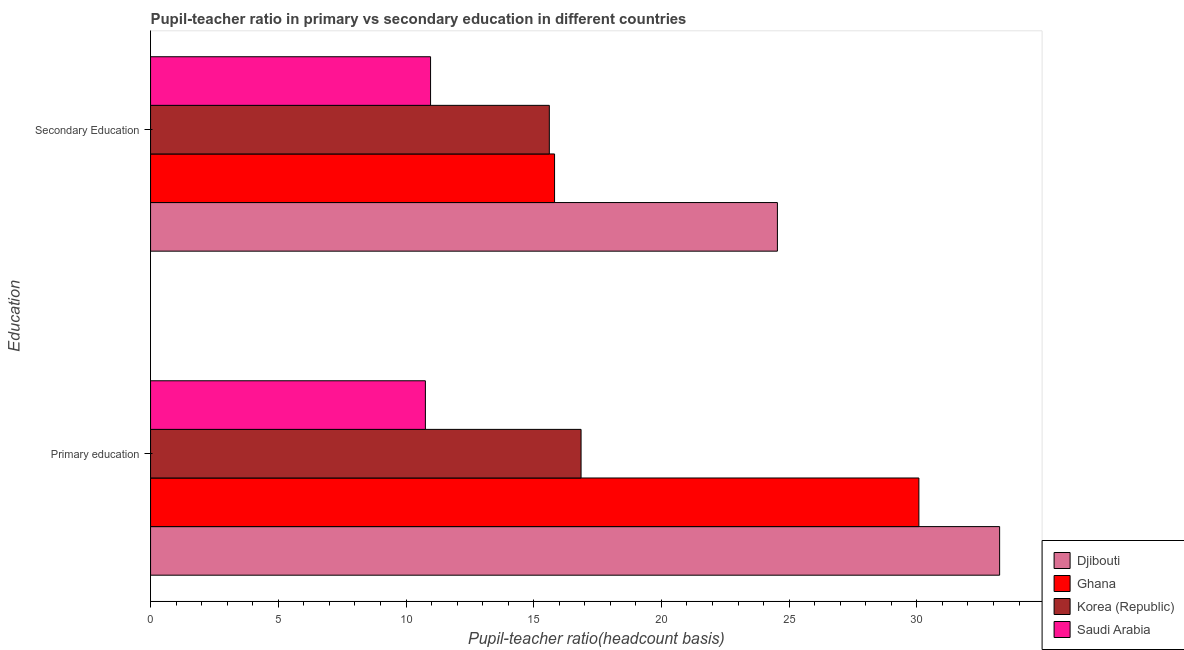Are the number of bars per tick equal to the number of legend labels?
Ensure brevity in your answer.  Yes. How many bars are there on the 1st tick from the top?
Provide a short and direct response. 4. What is the label of the 1st group of bars from the top?
Provide a short and direct response. Secondary Education. What is the pupil-teacher ratio in primary education in Saudi Arabia?
Provide a succinct answer. 10.76. Across all countries, what is the maximum pupil-teacher ratio in primary education?
Give a very brief answer. 33.24. Across all countries, what is the minimum pupil-teacher ratio in primary education?
Your answer should be very brief. 10.76. In which country was the pupil-teacher ratio in primary education maximum?
Make the answer very short. Djibouti. In which country was the pupil teacher ratio on secondary education minimum?
Offer a very short reply. Saudi Arabia. What is the total pupil teacher ratio on secondary education in the graph?
Keep it short and to the point. 66.93. What is the difference between the pupil teacher ratio on secondary education in Djibouti and that in Saudi Arabia?
Provide a short and direct response. 13.58. What is the difference between the pupil teacher ratio on secondary education in Saudi Arabia and the pupil-teacher ratio in primary education in Korea (Republic)?
Offer a very short reply. -5.89. What is the average pupil teacher ratio on secondary education per country?
Ensure brevity in your answer.  16.73. What is the difference between the pupil-teacher ratio in primary education and pupil teacher ratio on secondary education in Ghana?
Offer a very short reply. 14.26. What is the ratio of the pupil-teacher ratio in primary education in Djibouti to that in Saudi Arabia?
Offer a terse response. 3.09. In how many countries, is the pupil-teacher ratio in primary education greater than the average pupil-teacher ratio in primary education taken over all countries?
Offer a terse response. 2. What does the 3rd bar from the bottom in Secondary Education represents?
Provide a short and direct response. Korea (Republic). How many bars are there?
Make the answer very short. 8. Are all the bars in the graph horizontal?
Your response must be concise. Yes. Does the graph contain any zero values?
Offer a very short reply. No. Does the graph contain grids?
Make the answer very short. No. Where does the legend appear in the graph?
Your response must be concise. Bottom right. How many legend labels are there?
Provide a short and direct response. 4. How are the legend labels stacked?
Ensure brevity in your answer.  Vertical. What is the title of the graph?
Make the answer very short. Pupil-teacher ratio in primary vs secondary education in different countries. Does "Central African Republic" appear as one of the legend labels in the graph?
Your answer should be compact. No. What is the label or title of the X-axis?
Your answer should be compact. Pupil-teacher ratio(headcount basis). What is the label or title of the Y-axis?
Your answer should be compact. Education. What is the Pupil-teacher ratio(headcount basis) in Djibouti in Primary education?
Your answer should be very brief. 33.24. What is the Pupil-teacher ratio(headcount basis) of Ghana in Primary education?
Provide a short and direct response. 30.08. What is the Pupil-teacher ratio(headcount basis) of Korea (Republic) in Primary education?
Your response must be concise. 16.85. What is the Pupil-teacher ratio(headcount basis) of Saudi Arabia in Primary education?
Your answer should be compact. 10.76. What is the Pupil-teacher ratio(headcount basis) in Djibouti in Secondary Education?
Your answer should be very brief. 24.54. What is the Pupil-teacher ratio(headcount basis) of Ghana in Secondary Education?
Provide a short and direct response. 15.82. What is the Pupil-teacher ratio(headcount basis) in Korea (Republic) in Secondary Education?
Ensure brevity in your answer.  15.61. What is the Pupil-teacher ratio(headcount basis) of Saudi Arabia in Secondary Education?
Ensure brevity in your answer.  10.96. Across all Education, what is the maximum Pupil-teacher ratio(headcount basis) of Djibouti?
Keep it short and to the point. 33.24. Across all Education, what is the maximum Pupil-teacher ratio(headcount basis) of Ghana?
Your response must be concise. 30.08. Across all Education, what is the maximum Pupil-teacher ratio(headcount basis) in Korea (Republic)?
Your answer should be very brief. 16.85. Across all Education, what is the maximum Pupil-teacher ratio(headcount basis) in Saudi Arabia?
Your answer should be very brief. 10.96. Across all Education, what is the minimum Pupil-teacher ratio(headcount basis) in Djibouti?
Your answer should be very brief. 24.54. Across all Education, what is the minimum Pupil-teacher ratio(headcount basis) in Ghana?
Ensure brevity in your answer.  15.82. Across all Education, what is the minimum Pupil-teacher ratio(headcount basis) of Korea (Republic)?
Provide a short and direct response. 15.61. Across all Education, what is the minimum Pupil-teacher ratio(headcount basis) in Saudi Arabia?
Make the answer very short. 10.76. What is the total Pupil-teacher ratio(headcount basis) in Djibouti in the graph?
Provide a short and direct response. 57.78. What is the total Pupil-teacher ratio(headcount basis) of Ghana in the graph?
Offer a terse response. 45.89. What is the total Pupil-teacher ratio(headcount basis) of Korea (Republic) in the graph?
Ensure brevity in your answer.  32.46. What is the total Pupil-teacher ratio(headcount basis) in Saudi Arabia in the graph?
Make the answer very short. 21.72. What is the difference between the Pupil-teacher ratio(headcount basis) in Djibouti in Primary education and that in Secondary Education?
Your response must be concise. 8.7. What is the difference between the Pupil-teacher ratio(headcount basis) in Ghana in Primary education and that in Secondary Education?
Make the answer very short. 14.26. What is the difference between the Pupil-teacher ratio(headcount basis) in Korea (Republic) in Primary education and that in Secondary Education?
Keep it short and to the point. 1.24. What is the difference between the Pupil-teacher ratio(headcount basis) in Saudi Arabia in Primary education and that in Secondary Education?
Give a very brief answer. -0.2. What is the difference between the Pupil-teacher ratio(headcount basis) in Djibouti in Primary education and the Pupil-teacher ratio(headcount basis) in Ghana in Secondary Education?
Give a very brief answer. 17.42. What is the difference between the Pupil-teacher ratio(headcount basis) in Djibouti in Primary education and the Pupil-teacher ratio(headcount basis) in Korea (Republic) in Secondary Education?
Offer a terse response. 17.63. What is the difference between the Pupil-teacher ratio(headcount basis) in Djibouti in Primary education and the Pupil-teacher ratio(headcount basis) in Saudi Arabia in Secondary Education?
Keep it short and to the point. 22.28. What is the difference between the Pupil-teacher ratio(headcount basis) of Ghana in Primary education and the Pupil-teacher ratio(headcount basis) of Korea (Republic) in Secondary Education?
Your response must be concise. 14.47. What is the difference between the Pupil-teacher ratio(headcount basis) in Ghana in Primary education and the Pupil-teacher ratio(headcount basis) in Saudi Arabia in Secondary Education?
Offer a very short reply. 19.12. What is the difference between the Pupil-teacher ratio(headcount basis) in Korea (Republic) in Primary education and the Pupil-teacher ratio(headcount basis) in Saudi Arabia in Secondary Education?
Provide a short and direct response. 5.89. What is the average Pupil-teacher ratio(headcount basis) in Djibouti per Education?
Provide a succinct answer. 28.89. What is the average Pupil-teacher ratio(headcount basis) in Ghana per Education?
Provide a short and direct response. 22.95. What is the average Pupil-teacher ratio(headcount basis) in Korea (Republic) per Education?
Offer a very short reply. 16.23. What is the average Pupil-teacher ratio(headcount basis) in Saudi Arabia per Education?
Offer a very short reply. 10.86. What is the difference between the Pupil-teacher ratio(headcount basis) in Djibouti and Pupil-teacher ratio(headcount basis) in Ghana in Primary education?
Offer a very short reply. 3.16. What is the difference between the Pupil-teacher ratio(headcount basis) in Djibouti and Pupil-teacher ratio(headcount basis) in Korea (Republic) in Primary education?
Your answer should be very brief. 16.39. What is the difference between the Pupil-teacher ratio(headcount basis) of Djibouti and Pupil-teacher ratio(headcount basis) of Saudi Arabia in Primary education?
Your response must be concise. 22.48. What is the difference between the Pupil-teacher ratio(headcount basis) in Ghana and Pupil-teacher ratio(headcount basis) in Korea (Republic) in Primary education?
Offer a very short reply. 13.23. What is the difference between the Pupil-teacher ratio(headcount basis) of Ghana and Pupil-teacher ratio(headcount basis) of Saudi Arabia in Primary education?
Provide a succinct answer. 19.32. What is the difference between the Pupil-teacher ratio(headcount basis) of Korea (Republic) and Pupil-teacher ratio(headcount basis) of Saudi Arabia in Primary education?
Your answer should be compact. 6.09. What is the difference between the Pupil-teacher ratio(headcount basis) of Djibouti and Pupil-teacher ratio(headcount basis) of Ghana in Secondary Education?
Keep it short and to the point. 8.72. What is the difference between the Pupil-teacher ratio(headcount basis) of Djibouti and Pupil-teacher ratio(headcount basis) of Korea (Republic) in Secondary Education?
Offer a very short reply. 8.93. What is the difference between the Pupil-teacher ratio(headcount basis) in Djibouti and Pupil-teacher ratio(headcount basis) in Saudi Arabia in Secondary Education?
Offer a very short reply. 13.58. What is the difference between the Pupil-teacher ratio(headcount basis) in Ghana and Pupil-teacher ratio(headcount basis) in Korea (Republic) in Secondary Education?
Keep it short and to the point. 0.2. What is the difference between the Pupil-teacher ratio(headcount basis) in Ghana and Pupil-teacher ratio(headcount basis) in Saudi Arabia in Secondary Education?
Ensure brevity in your answer.  4.85. What is the difference between the Pupil-teacher ratio(headcount basis) of Korea (Republic) and Pupil-teacher ratio(headcount basis) of Saudi Arabia in Secondary Education?
Offer a very short reply. 4.65. What is the ratio of the Pupil-teacher ratio(headcount basis) in Djibouti in Primary education to that in Secondary Education?
Give a very brief answer. 1.35. What is the ratio of the Pupil-teacher ratio(headcount basis) of Ghana in Primary education to that in Secondary Education?
Ensure brevity in your answer.  1.9. What is the ratio of the Pupil-teacher ratio(headcount basis) in Korea (Republic) in Primary education to that in Secondary Education?
Provide a short and direct response. 1.08. What is the ratio of the Pupil-teacher ratio(headcount basis) in Saudi Arabia in Primary education to that in Secondary Education?
Keep it short and to the point. 0.98. What is the difference between the highest and the second highest Pupil-teacher ratio(headcount basis) in Djibouti?
Offer a very short reply. 8.7. What is the difference between the highest and the second highest Pupil-teacher ratio(headcount basis) of Ghana?
Provide a short and direct response. 14.26. What is the difference between the highest and the second highest Pupil-teacher ratio(headcount basis) of Korea (Republic)?
Your answer should be compact. 1.24. What is the difference between the highest and the second highest Pupil-teacher ratio(headcount basis) in Saudi Arabia?
Your response must be concise. 0.2. What is the difference between the highest and the lowest Pupil-teacher ratio(headcount basis) in Djibouti?
Make the answer very short. 8.7. What is the difference between the highest and the lowest Pupil-teacher ratio(headcount basis) in Ghana?
Provide a succinct answer. 14.26. What is the difference between the highest and the lowest Pupil-teacher ratio(headcount basis) in Korea (Republic)?
Ensure brevity in your answer.  1.24. What is the difference between the highest and the lowest Pupil-teacher ratio(headcount basis) in Saudi Arabia?
Keep it short and to the point. 0.2. 